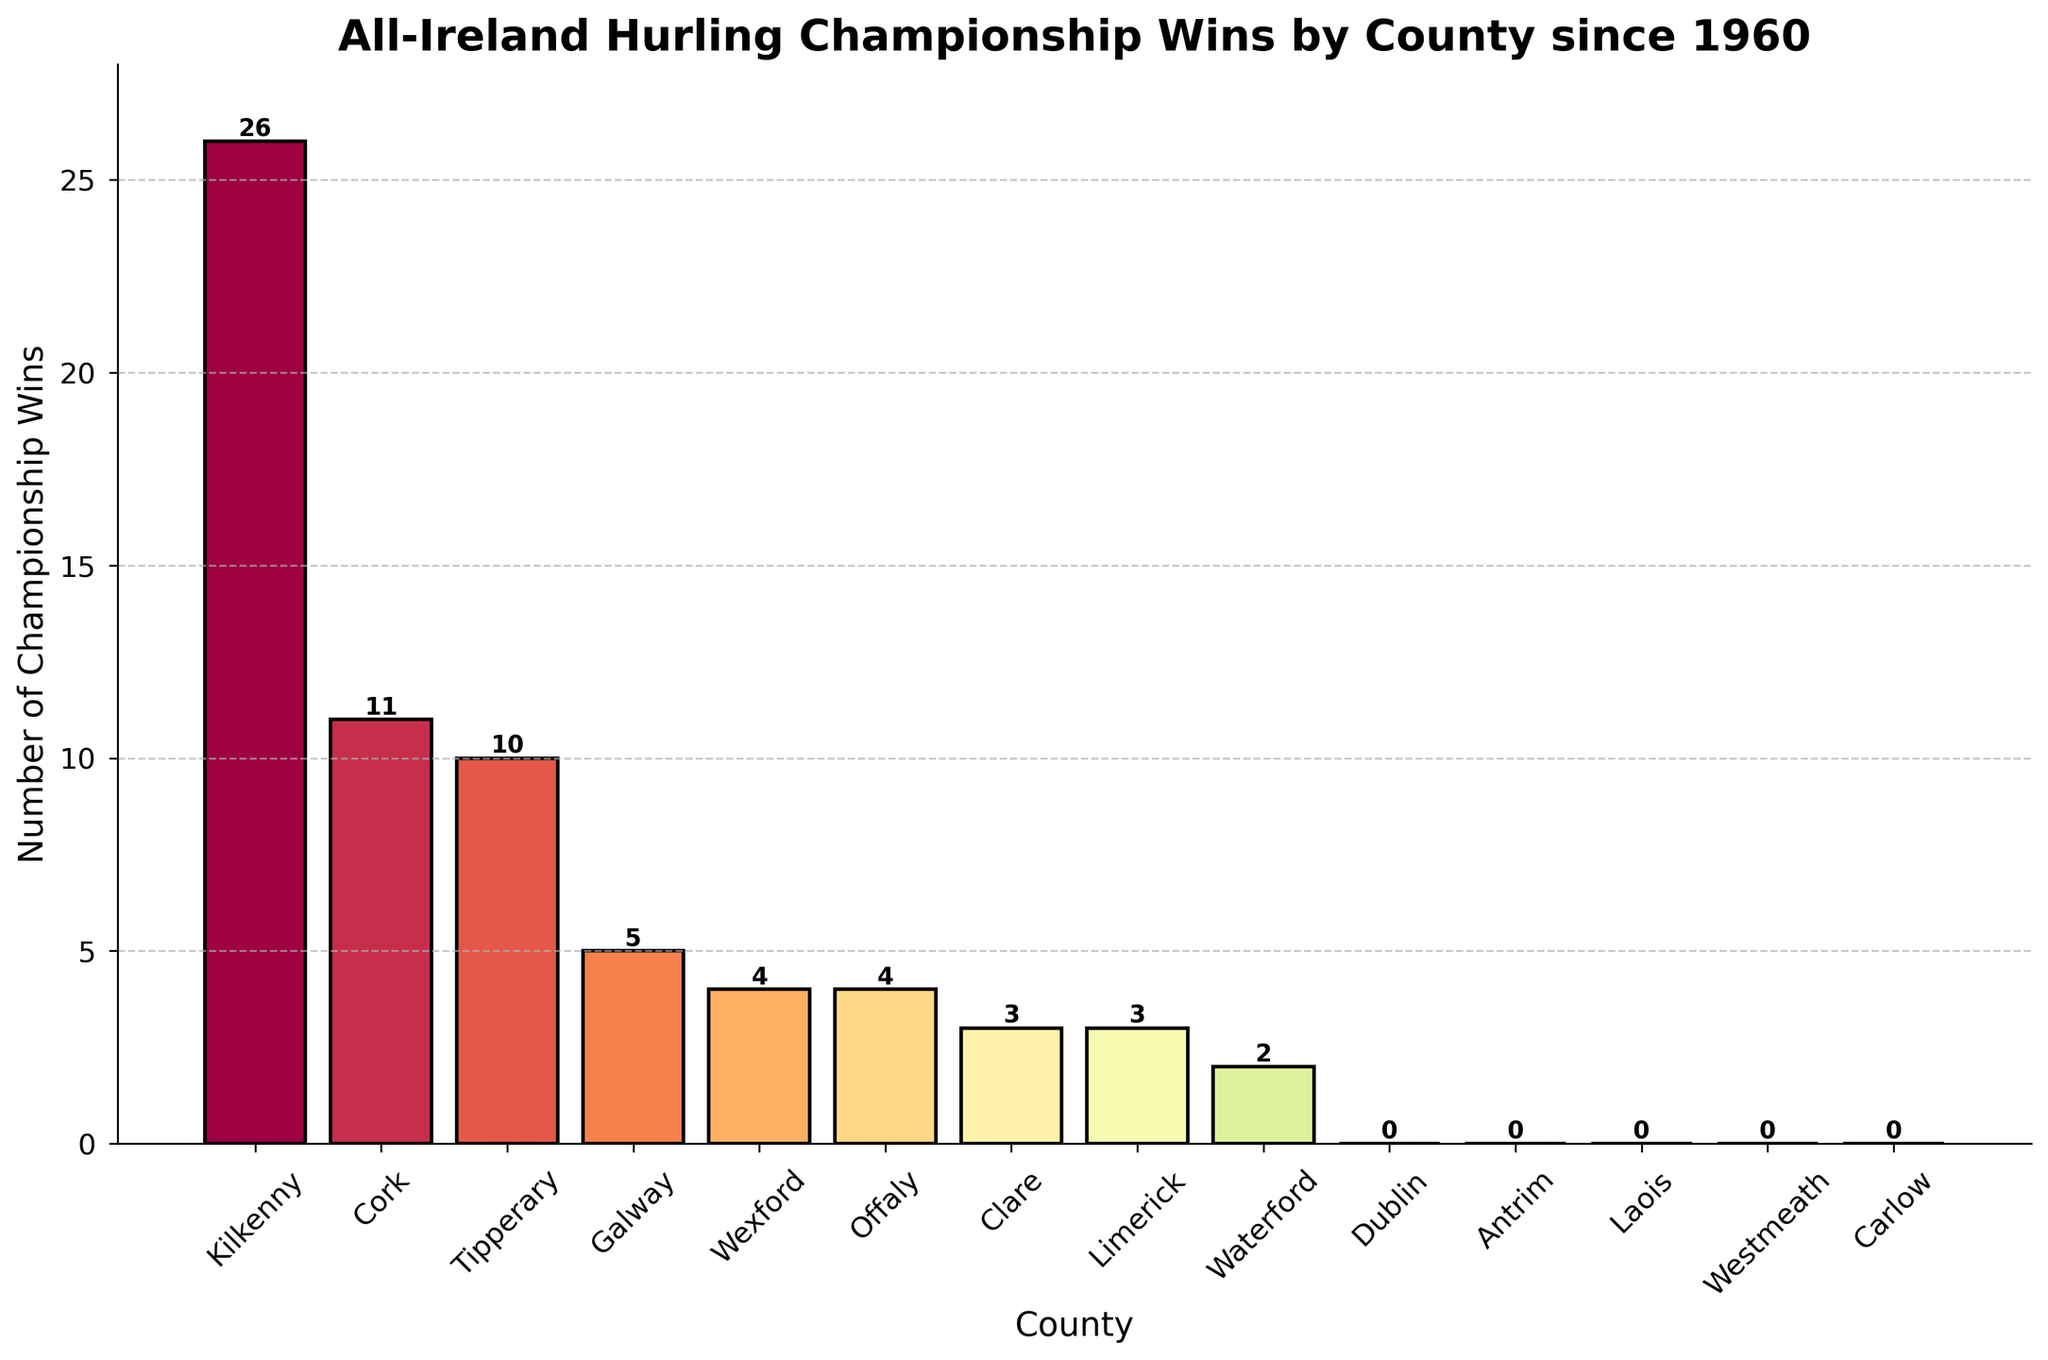Which county has the most All-Ireland Hurling Championship wins since 1960? Look at the bar heights to determine which one is the tallest. The tallest bar corresponds to Kilkenny with 26 wins.
Answer: Kilkenny How many championships have been won by counties that have at least one win but fewer than 10 wins? Look at the counties with win totals of 1 through 9 and sum their wins: Galway (5), Wexford (4), Offaly (4), Clare (3), Limerick (3), Waterford (2). Adding them gives 21.
Answer: 21 Which counties have fewer than 5 wins but more than 1 win? Identify the bars whose heights are between 1 and 5: Clare (3), Limerick (3), Waterford (2).
Answer: Clare, Limerick, Waterford What is the combined total of championship wins for Cork and Tipperary? Sum the wins of Cork and Tipperary: Cork (11) + Tipperary (10) = 21.
Answer: 21 Are there any counties that have not won an All-Ireland Hurling Championship since 1960? Look at the bars with a height of 0: Dublin, Antrim, Laois, Westmeath, Carlow.
Answer: Yes What is the difference in championship wins between Kilkenny and Cork? Subtract the number of wins of Cork from Kilkenny: 26 (Kilkenny) - 11 (Cork) = 15.
Answer: 15 If you combine the wins of the top two counties, do they make up more than half of all the wins recorded? First, combine the wins of Kilkenny and Cork: 26 + 11 = 37. Then, sum all the wins in the dataset: 26 + 11 + 10 + 5 + 4 + 4 + 3 + 3 + 2 = 68. Check if 37 is more than half of 68, which is 34. Yes, it's more than half.
Answer: Yes Which counties have three wins each? Observe the bars with a height of 3: Clare and Limerick.
Answer: Clare, Limerick 